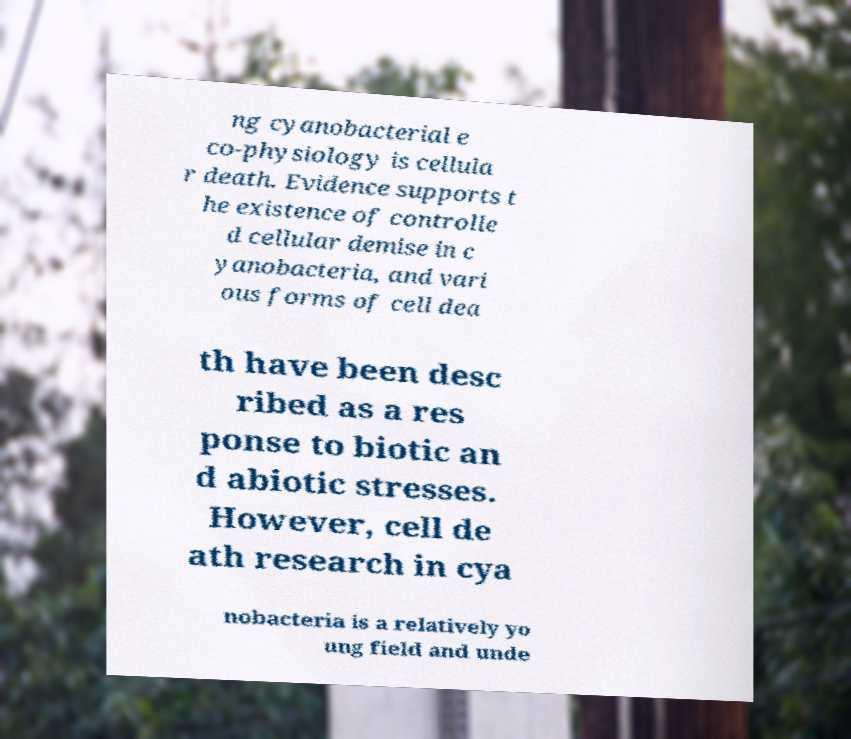For documentation purposes, I need the text within this image transcribed. Could you provide that? ng cyanobacterial e co-physiology is cellula r death. Evidence supports t he existence of controlle d cellular demise in c yanobacteria, and vari ous forms of cell dea th have been desc ribed as a res ponse to biotic an d abiotic stresses. However, cell de ath research in cya nobacteria is a relatively yo ung field and unde 